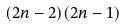Convert formula to latex. <formula><loc_0><loc_0><loc_500><loc_500>( 2 n - 2 ) ( 2 n - 1 )</formula> 